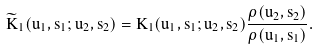Convert formula to latex. <formula><loc_0><loc_0><loc_500><loc_500>\widetilde { K } _ { 1 } ( u _ { 1 } , s _ { 1 } ; u _ { 2 } , s _ { 2 } ) = K _ { 1 } ( u _ { 1 } , s _ { 1 } ; u _ { 2 } , s _ { 2 } ) \frac { \rho ( u _ { 2 } , s _ { 2 } ) } { \rho ( u _ { 1 } , s _ { 1 } ) } .</formula> 